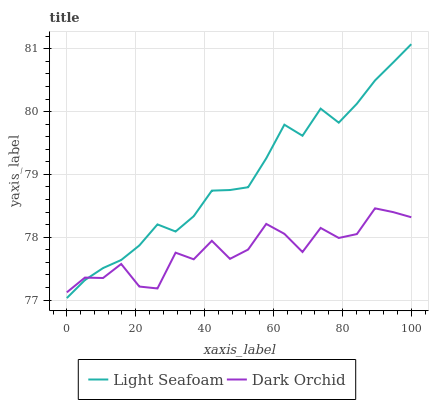Does Dark Orchid have the minimum area under the curve?
Answer yes or no. Yes. Does Light Seafoam have the maximum area under the curve?
Answer yes or no. Yes. Does Dark Orchid have the maximum area under the curve?
Answer yes or no. No. Is Light Seafoam the smoothest?
Answer yes or no. Yes. Is Dark Orchid the roughest?
Answer yes or no. Yes. Is Dark Orchid the smoothest?
Answer yes or no. No. Does Light Seafoam have the lowest value?
Answer yes or no. Yes. Does Dark Orchid have the lowest value?
Answer yes or no. No. Does Light Seafoam have the highest value?
Answer yes or no. Yes. Does Dark Orchid have the highest value?
Answer yes or no. No. Does Dark Orchid intersect Light Seafoam?
Answer yes or no. Yes. Is Dark Orchid less than Light Seafoam?
Answer yes or no. No. Is Dark Orchid greater than Light Seafoam?
Answer yes or no. No. 